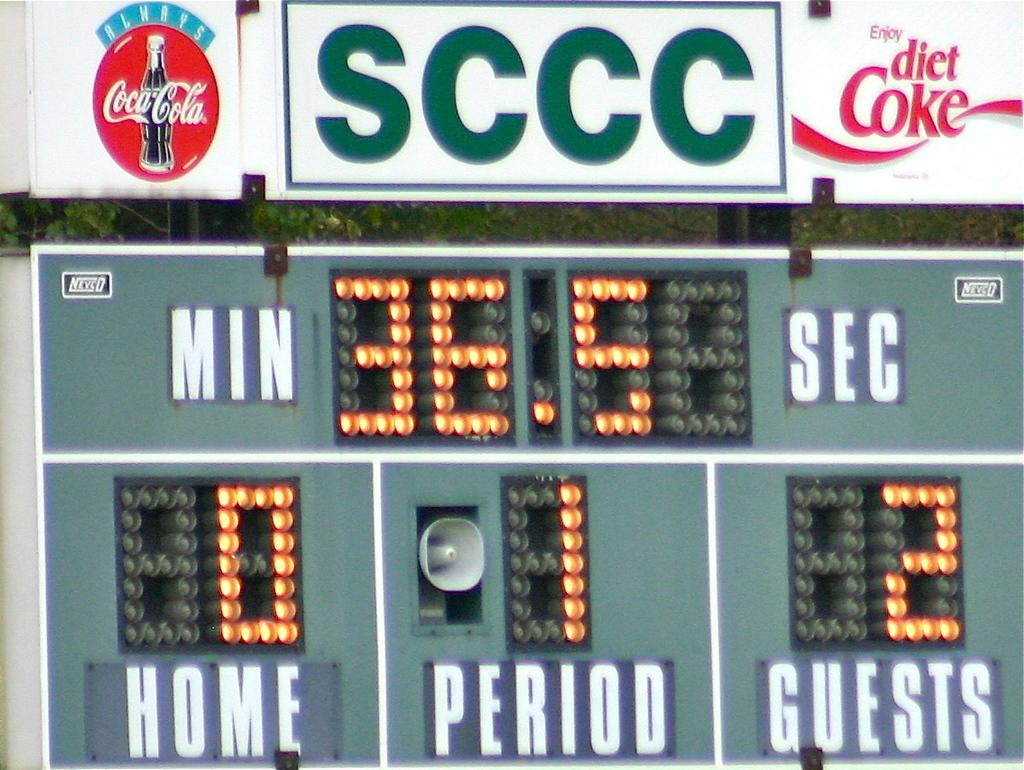<image>
Render a clear and concise summary of the photo. A sports scoreboard from SCCC with diet coke advertising on it. 